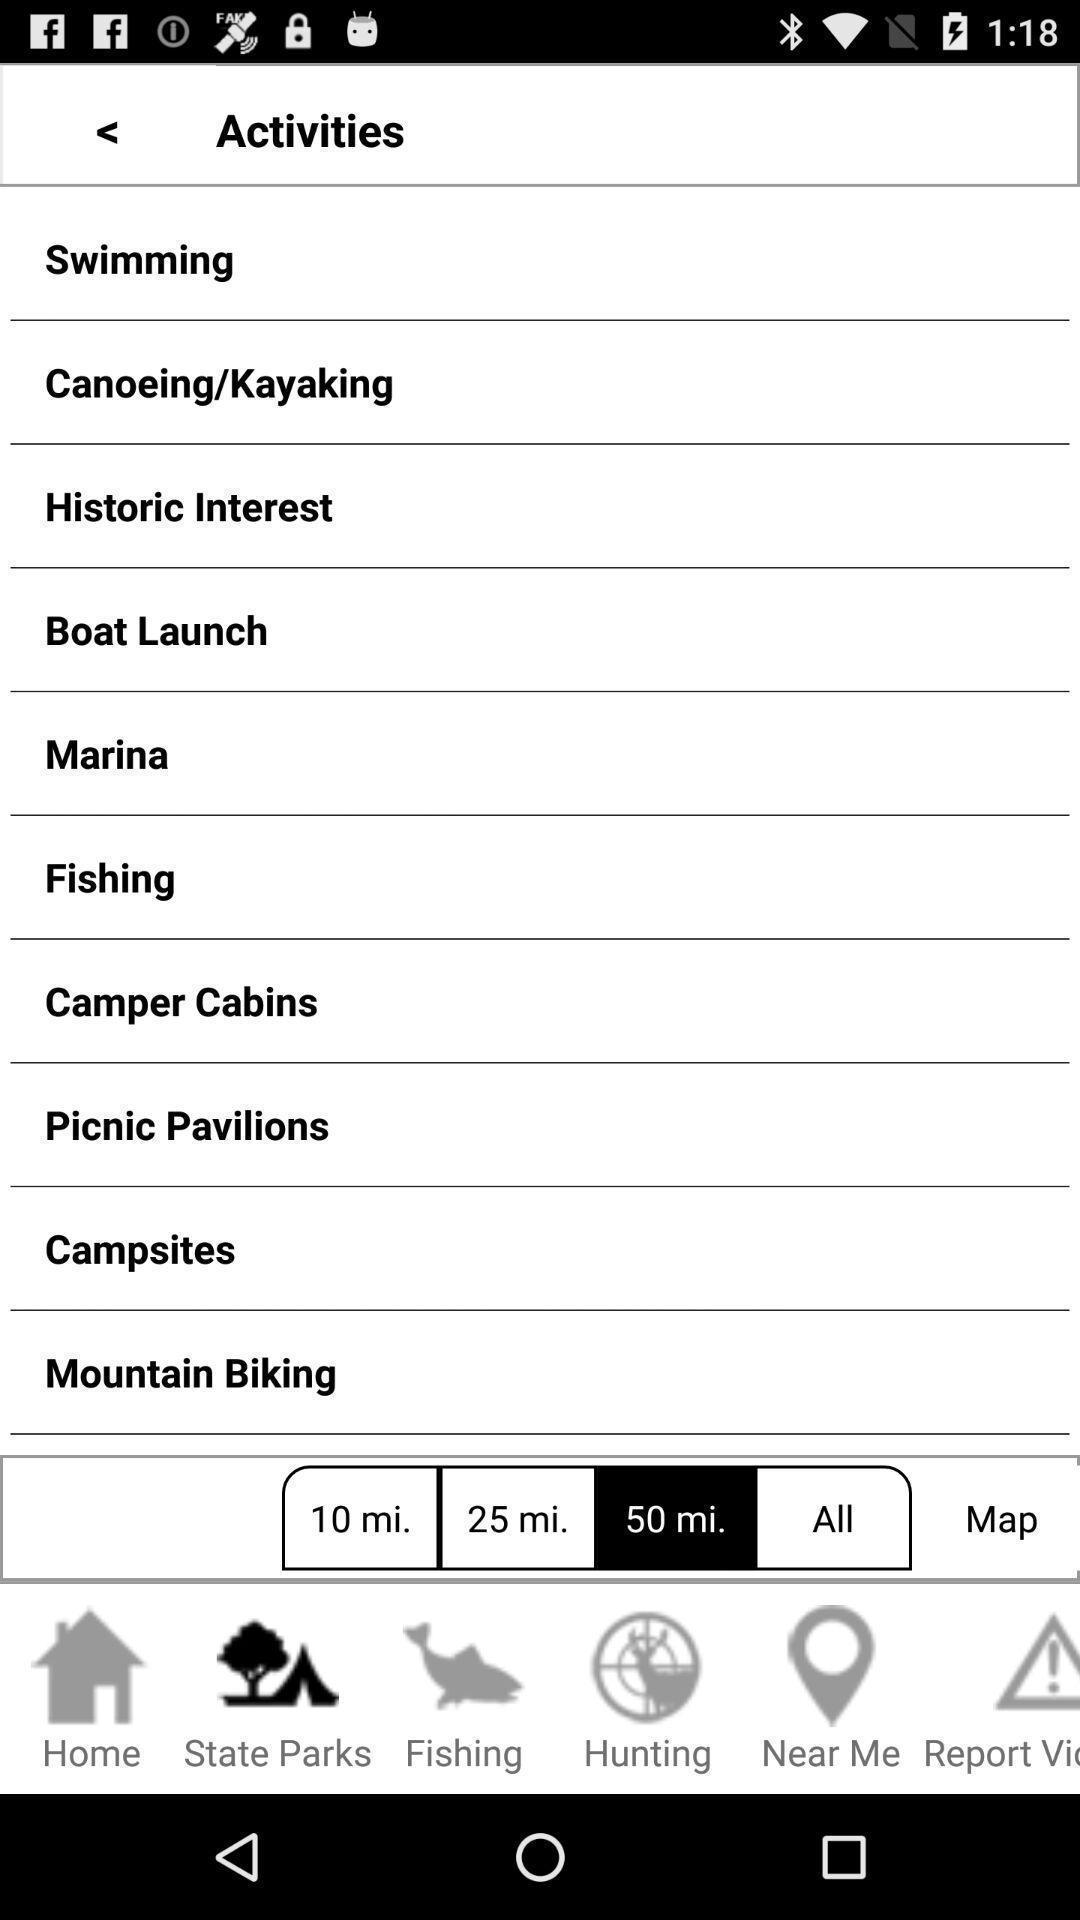Explain what's happening in this screen capture. Screen displays various activities. 